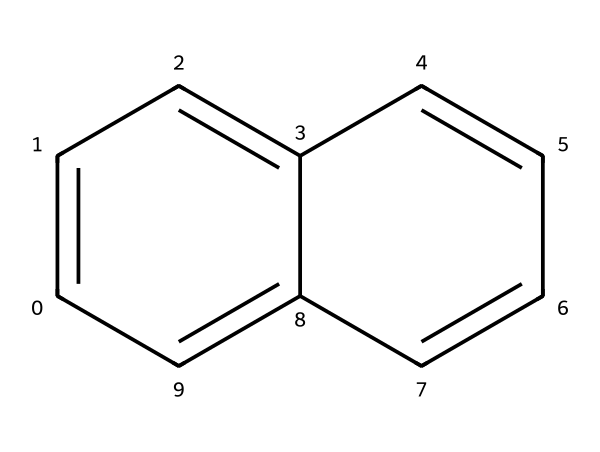What is the name of the compound represented by this SMILES? The SMILES notation indicates a polycyclic aromatic compound with two fused benzene rings, which is naphthalene.
Answer: naphthalene How many carbon atoms are present in naphthalene? By analyzing the structure from the SMILES, we can count a total of ten carbon atoms within the fused rings of naphthalene.
Answer: ten What is the total number of hydrogen atoms in naphthalene? Each carbon in naphthalene is bonded to one hydrogen, resulting in eight hydrogen atoms after accounting for the structure's connectivity.
Answer: eight What type of hybridization do the carbon atoms in naphthalene exhibit? The carbon atoms in naphthalene are involved in sp2 hybridization due to their participation in double bonds and planar ring structure.
Answer: sp2 What is the bond angle around the carbon atoms in naphthalene? The bond angles around the sp2 hybridized carbon atoms are typically around 120 degrees, characteristic of planar structures.
Answer: 120 degrees How many π electrons are delocalized in naphthalene? Naphthalene has a total of six π electrons from the three double bonds in its structure, following Huckel's rule for aromaticity.
Answer: six What is the significance of naphthalene's aromatic stability in synthesis? Naphthalene's aromatic nature contributes to its stability, making it a valuable intermediate in various organic synthesis processes.
Answer: aromatic stability 